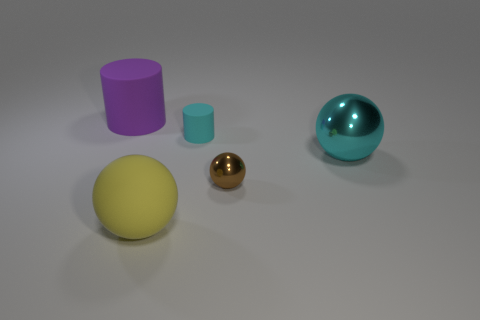Add 1 big yellow matte spheres. How many objects exist? 6 Subtract all cylinders. How many objects are left? 3 Subtract 0 blue balls. How many objects are left? 5 Subtract all brown shiny objects. Subtract all tiny rubber cylinders. How many objects are left? 3 Add 5 purple matte cylinders. How many purple matte cylinders are left? 6 Add 1 large purple matte balls. How many large purple matte balls exist? 1 